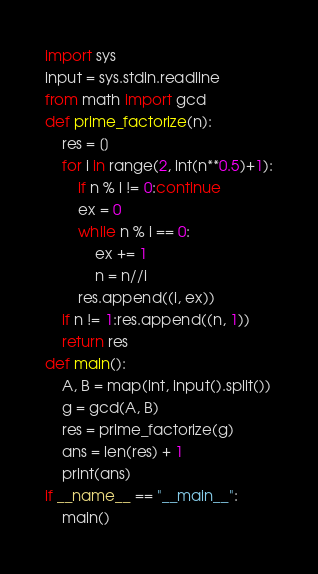<code> <loc_0><loc_0><loc_500><loc_500><_Python_>import sys
input = sys.stdin.readline
from math import gcd
def prime_factorize(n):
    res = []
    for i in range(2, int(n**0.5)+1):
        if n % i != 0:continue
        ex = 0
        while n % i == 0:
            ex += 1
            n = n//i
        res.append((i, ex))
    if n != 1:res.append((n, 1))
    return res
def main():
    A, B = map(int, input().split())
    g = gcd(A, B)
    res = prime_factorize(g)
    ans = len(res) + 1
    print(ans)
if __name__ == "__main__":
    main()</code> 